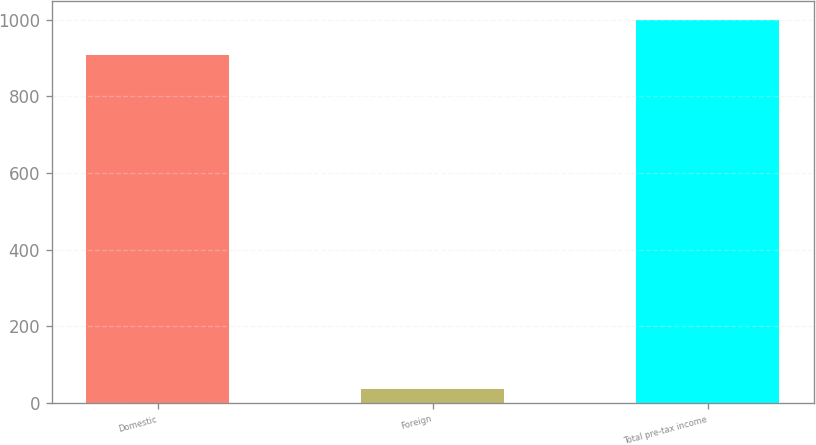Convert chart. <chart><loc_0><loc_0><loc_500><loc_500><bar_chart><fcel>Domestic<fcel>Foreign<fcel>Total pre-tax income<nl><fcel>909<fcel>35.2<fcel>999.9<nl></chart> 